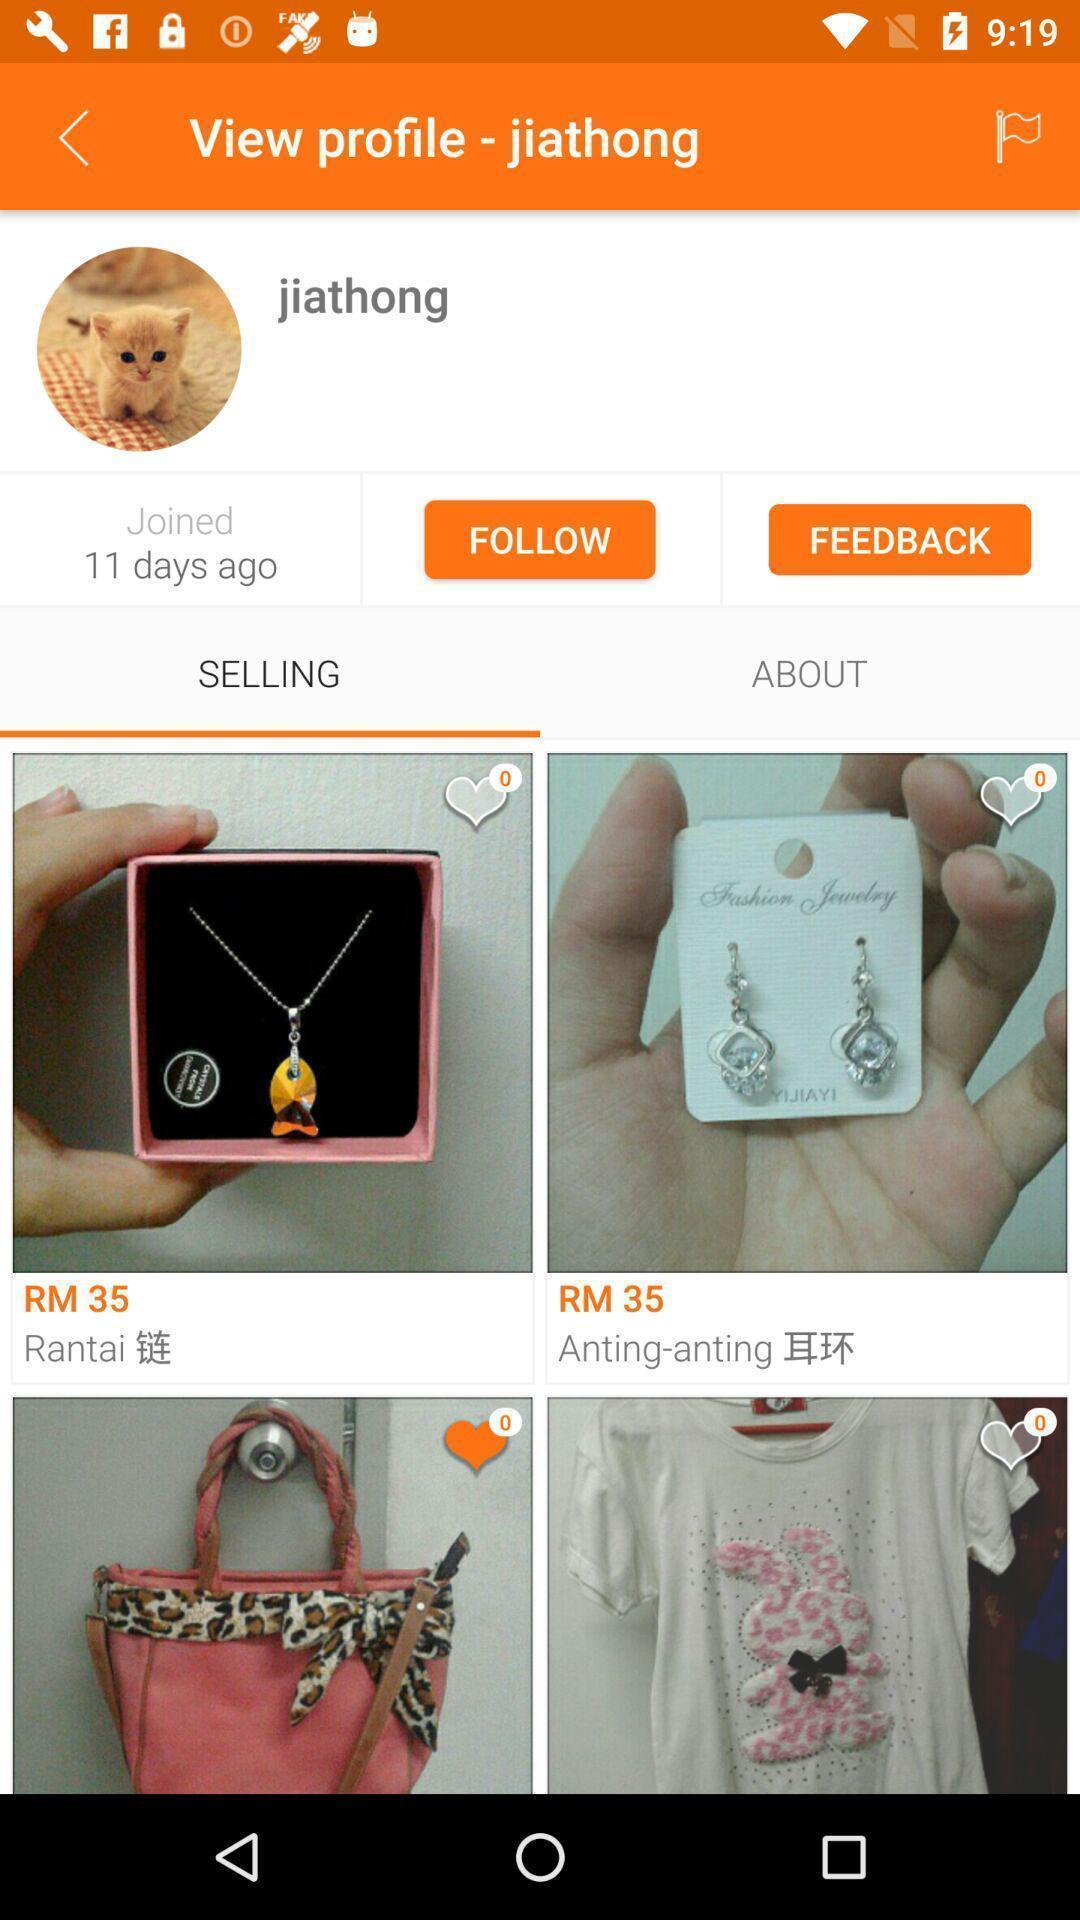Tell me about the visual elements in this screen capture. Page showing profile of an social app. 